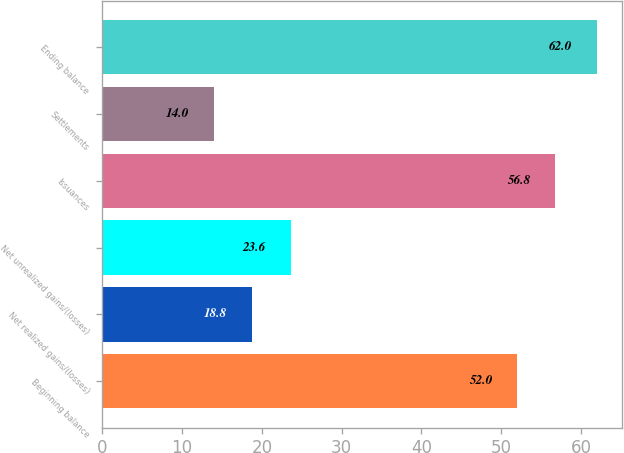<chart> <loc_0><loc_0><loc_500><loc_500><bar_chart><fcel>Beginning balance<fcel>Net realized gains/(losses)<fcel>Net unrealized gains/(losses)<fcel>Issuances<fcel>Settlements<fcel>Ending balance<nl><fcel>52<fcel>18.8<fcel>23.6<fcel>56.8<fcel>14<fcel>62<nl></chart> 